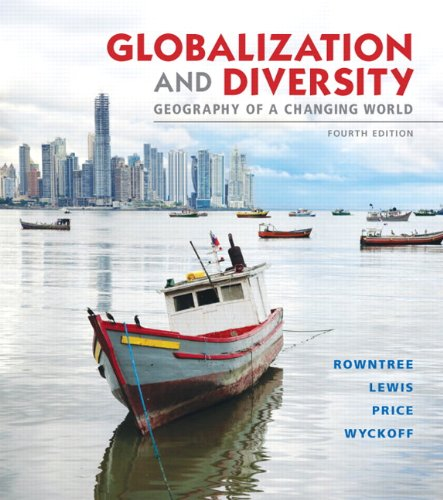What type of book is this? This book falls under the category of Science & Math, with a specific focus on geography, exploring the dynamic and diverse aspects of globalization. 